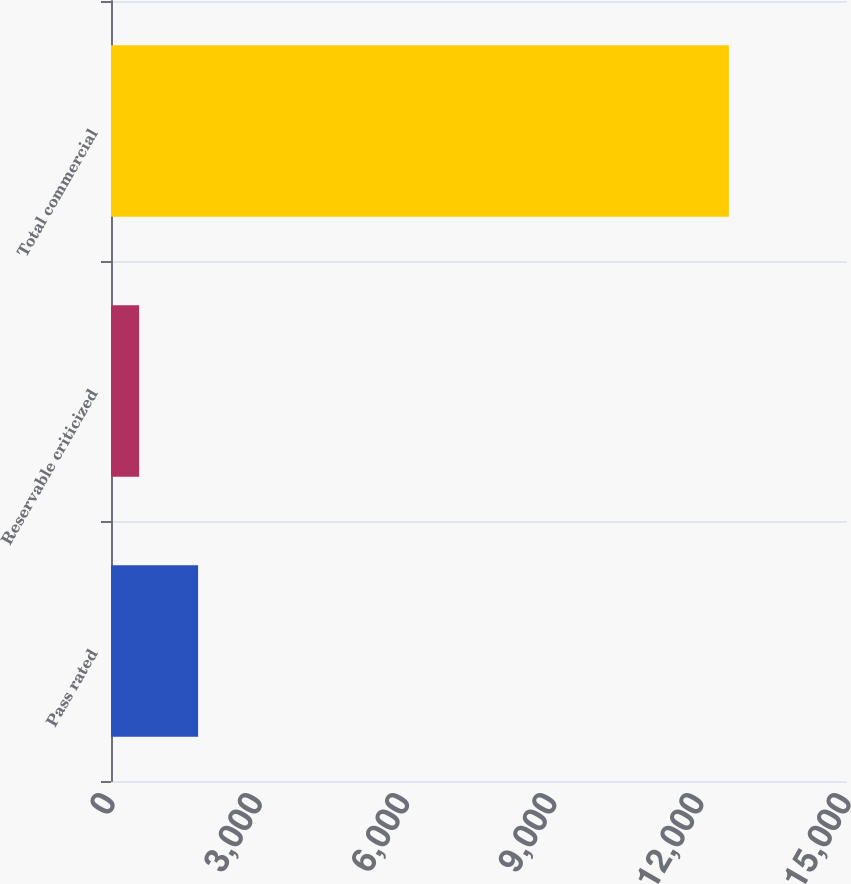<chart> <loc_0><loc_0><loc_500><loc_500><bar_chart><fcel>Pass rated<fcel>Reservable criticized<fcel>Total commercial<nl><fcel>1775<fcel>573<fcel>12593<nl></chart> 